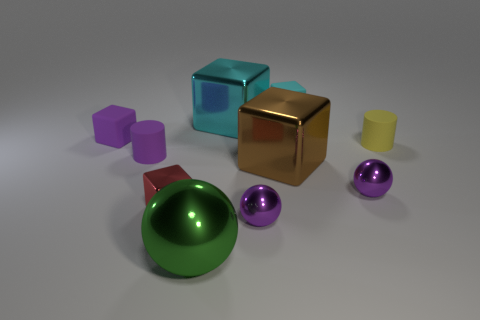There is a shiny block that is behind the tiny purple block; is its color the same as the tiny rubber block that is to the right of the tiny purple cube?
Provide a short and direct response. Yes. There is a purple shiny sphere that is in front of the shiny sphere that is to the right of the cyan object behind the large cyan block; what size is it?
Give a very brief answer. Small. The thing that is in front of the small yellow matte object and to the right of the brown metal block has what shape?
Keep it short and to the point. Sphere. Is the number of matte cylinders in front of the green object the same as the number of brown objects left of the cyan matte object?
Give a very brief answer. No. Is there a cyan cube that has the same material as the small red thing?
Keep it short and to the point. Yes. Are the cylinder that is on the right side of the purple cylinder and the big cyan block made of the same material?
Make the answer very short. No. There is a cube that is left of the large cyan cube and in front of the small purple matte cylinder; what is its size?
Offer a very short reply. Small. The large ball has what color?
Ensure brevity in your answer.  Green. How many large green things are there?
Provide a short and direct response. 1. Is the shape of the large thing that is behind the brown thing the same as the small purple metallic thing on the left side of the tiny cyan rubber object?
Your answer should be very brief. No. 